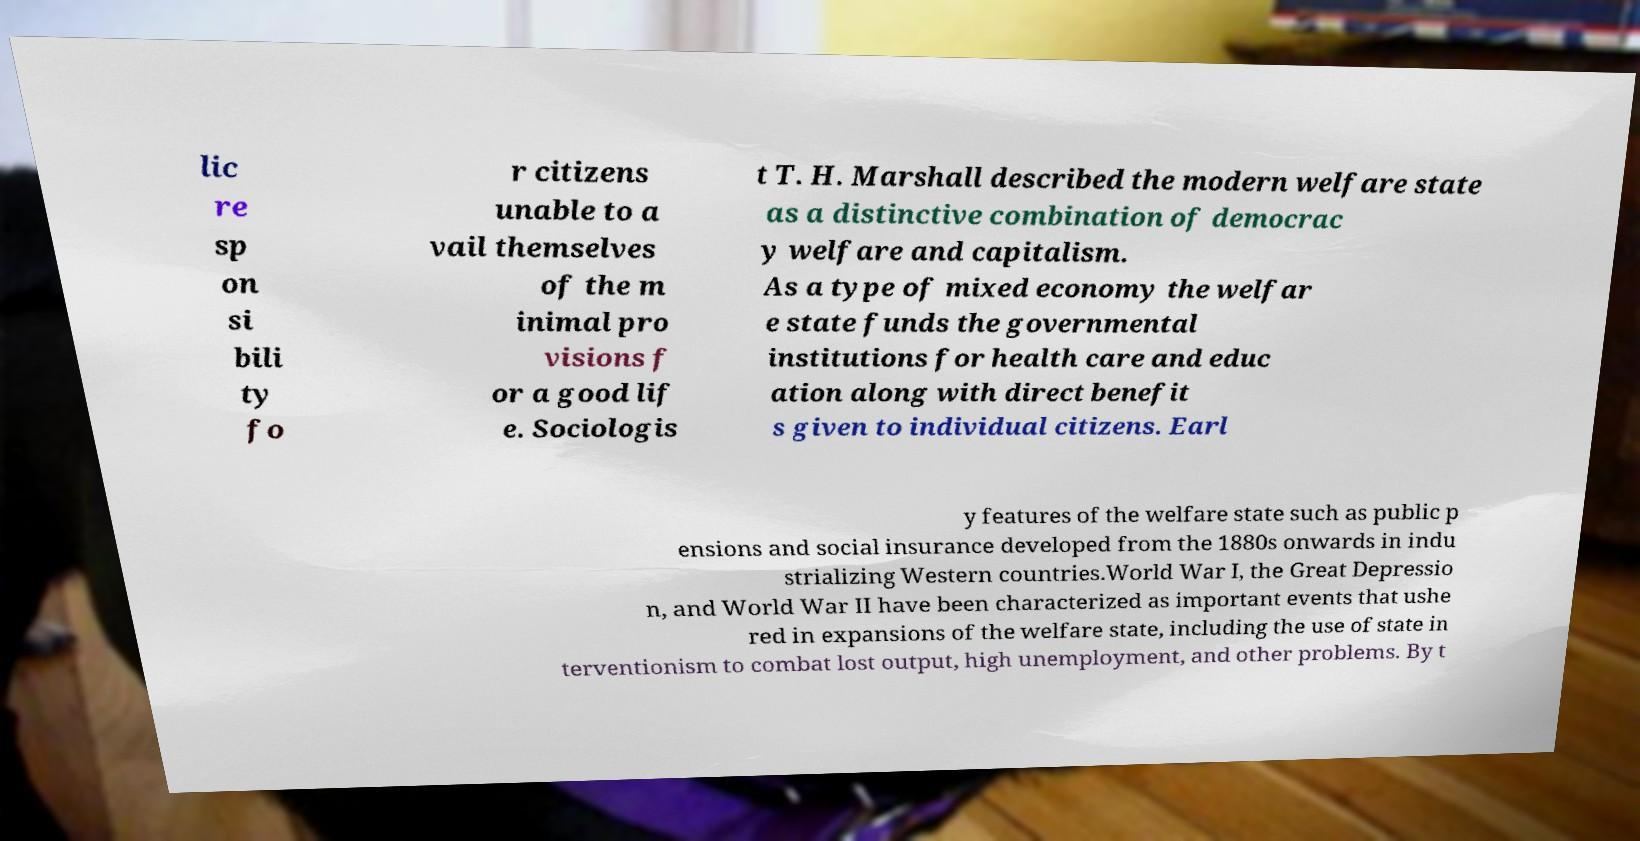I need the written content from this picture converted into text. Can you do that? lic re sp on si bili ty fo r citizens unable to a vail themselves of the m inimal pro visions f or a good lif e. Sociologis t T. H. Marshall described the modern welfare state as a distinctive combination of democrac y welfare and capitalism. As a type of mixed economy the welfar e state funds the governmental institutions for health care and educ ation along with direct benefit s given to individual citizens. Earl y features of the welfare state such as public p ensions and social insurance developed from the 1880s onwards in indu strializing Western countries.World War I, the Great Depressio n, and World War II have been characterized as important events that ushe red in expansions of the welfare state, including the use of state in terventionism to combat lost output, high unemployment, and other problems. By t 